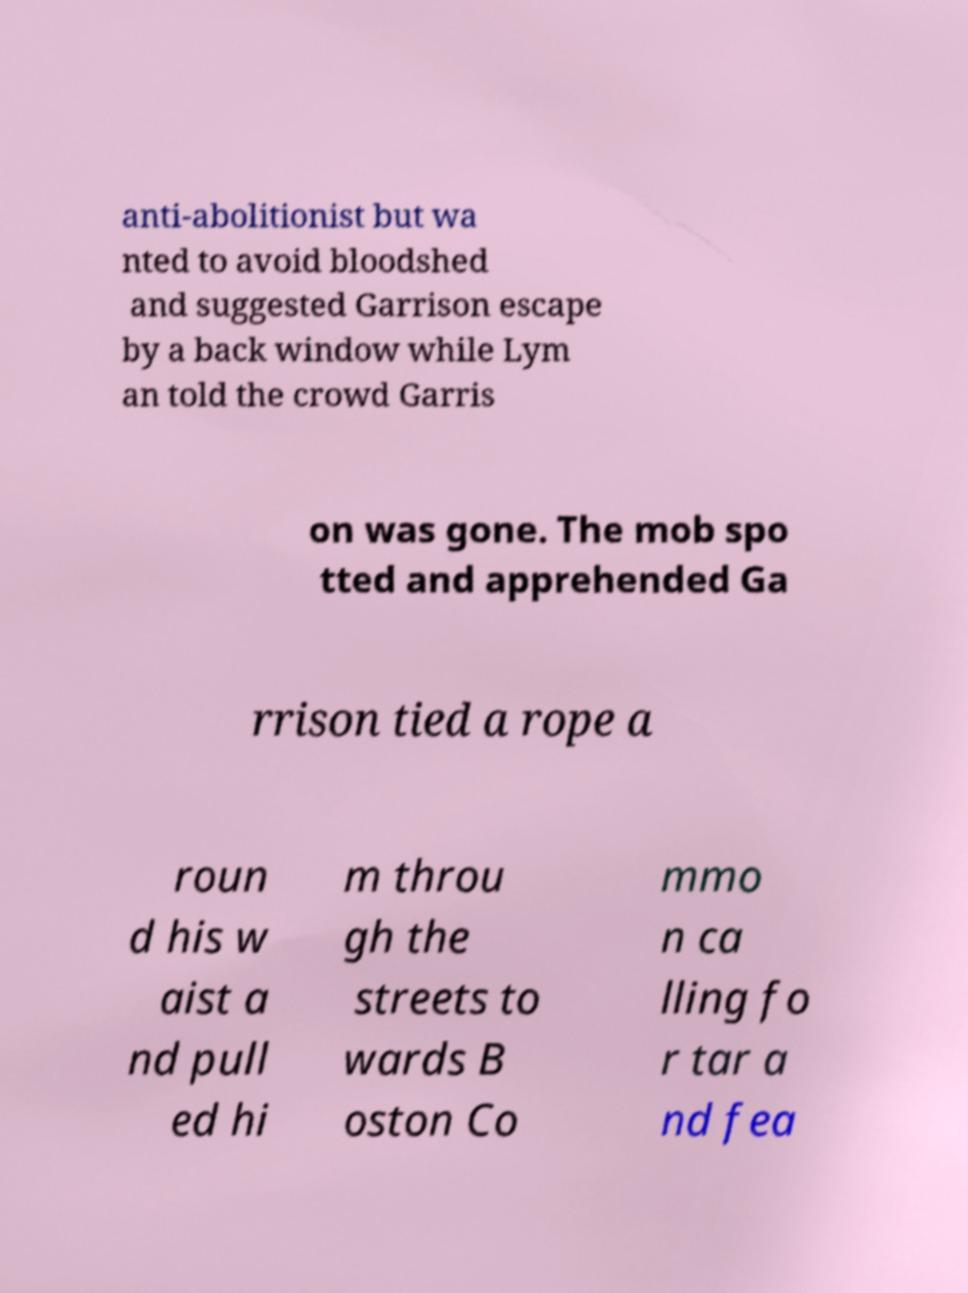Can you accurately transcribe the text from the provided image for me? anti-abolitionist but wa nted to avoid bloodshed and suggested Garrison escape by a back window while Lym an told the crowd Garris on was gone. The mob spo tted and apprehended Ga rrison tied a rope a roun d his w aist a nd pull ed hi m throu gh the streets to wards B oston Co mmo n ca lling fo r tar a nd fea 